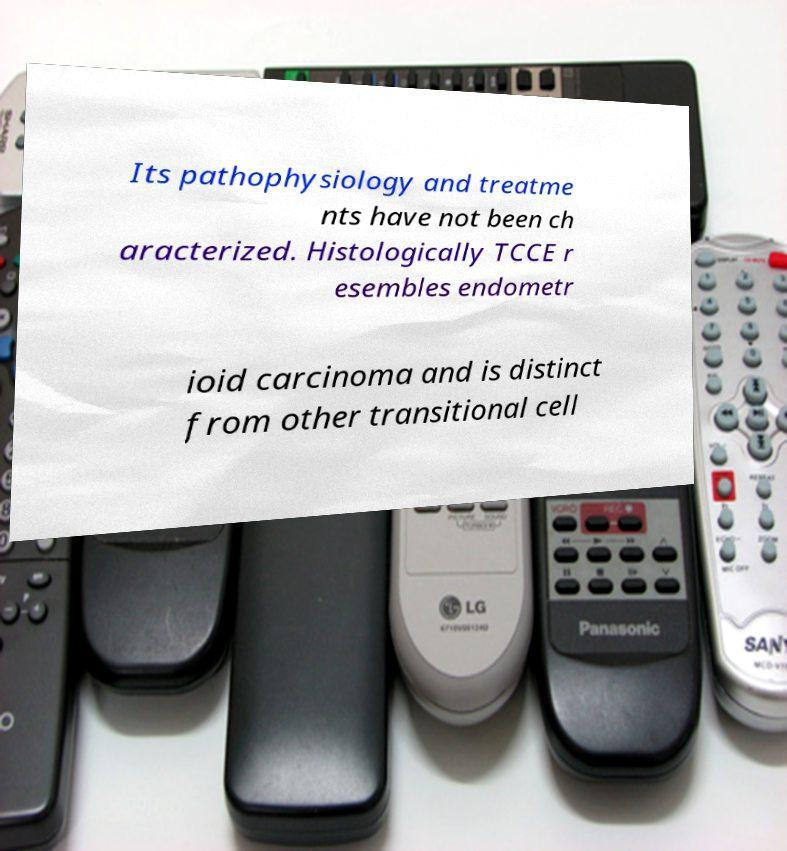For documentation purposes, I need the text within this image transcribed. Could you provide that? Its pathophysiology and treatme nts have not been ch aracterized. Histologically TCCE r esembles endometr ioid carcinoma and is distinct from other transitional cell 